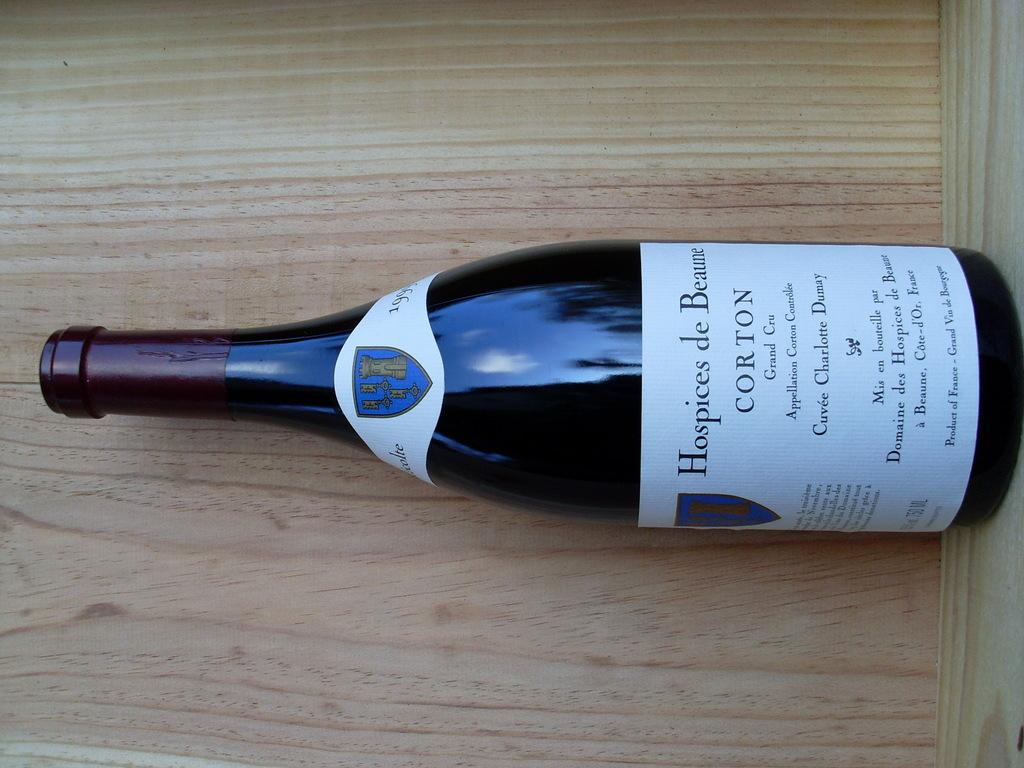<image>
Offer a succinct explanation of the picture presented. A bottle of Corton from the Hospices de Beaune. 